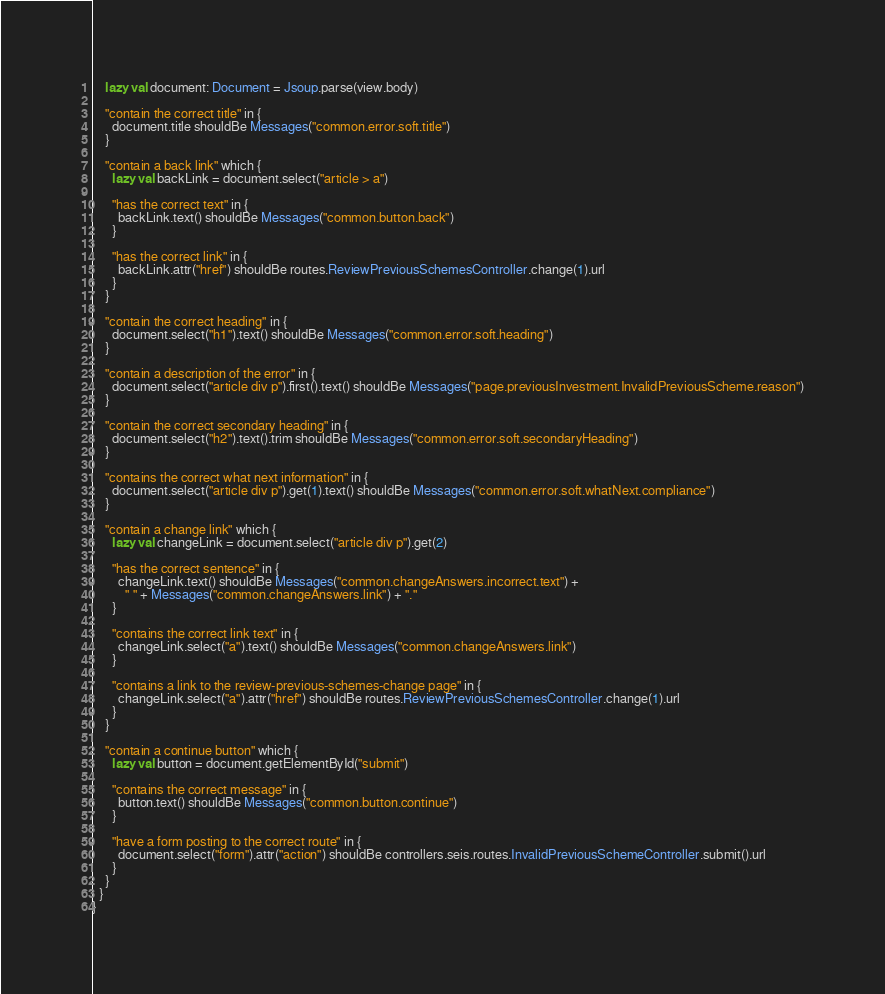<code> <loc_0><loc_0><loc_500><loc_500><_Scala_>    lazy val document: Document = Jsoup.parse(view.body)

    "contain the correct title" in {
      document.title shouldBe Messages("common.error.soft.title")
    }

    "contain a back link" which {
      lazy val backLink = document.select("article > a")

      "has the correct text" in {
        backLink.text() shouldBe Messages("common.button.back")
      }

      "has the correct link" in {
        backLink.attr("href") shouldBe routes.ReviewPreviousSchemesController.change(1).url
      }
    }

    "contain the correct heading" in {
      document.select("h1").text() shouldBe Messages("common.error.soft.heading")
    }

    "contain a description of the error" in {
      document.select("article div p").first().text() shouldBe Messages("page.previousInvestment.InvalidPreviousScheme.reason")
    }

    "contain the correct secondary heading" in {
      document.select("h2").text().trim shouldBe Messages("common.error.soft.secondaryHeading")
    }

    "contains the correct what next information" in {
      document.select("article div p").get(1).text() shouldBe Messages("common.error.soft.whatNext.compliance")
    }

    "contain a change link" which {
      lazy val changeLink = document.select("article div p").get(2)

      "has the correct sentence" in {
        changeLink.text() shouldBe Messages("common.changeAnswers.incorrect.text") +
          " " + Messages("common.changeAnswers.link") + "."
      }

      "contains the correct link text" in {
        changeLink.select("a").text() shouldBe Messages("common.changeAnswers.link")
      }

      "contains a link to the review-previous-schemes-change page" in {
        changeLink.select("a").attr("href") shouldBe routes.ReviewPreviousSchemesController.change(1).url
      }
    }

    "contain a continue button" which {
      lazy val button = document.getElementById("submit")

      "contains the correct message" in {
        button.text() shouldBe Messages("common.button.continue")
      }

      "have a form posting to the correct route" in {
        document.select("form").attr("action") shouldBe controllers.seis.routes.InvalidPreviousSchemeController.submit().url
      }
    }
  }
}
</code> 